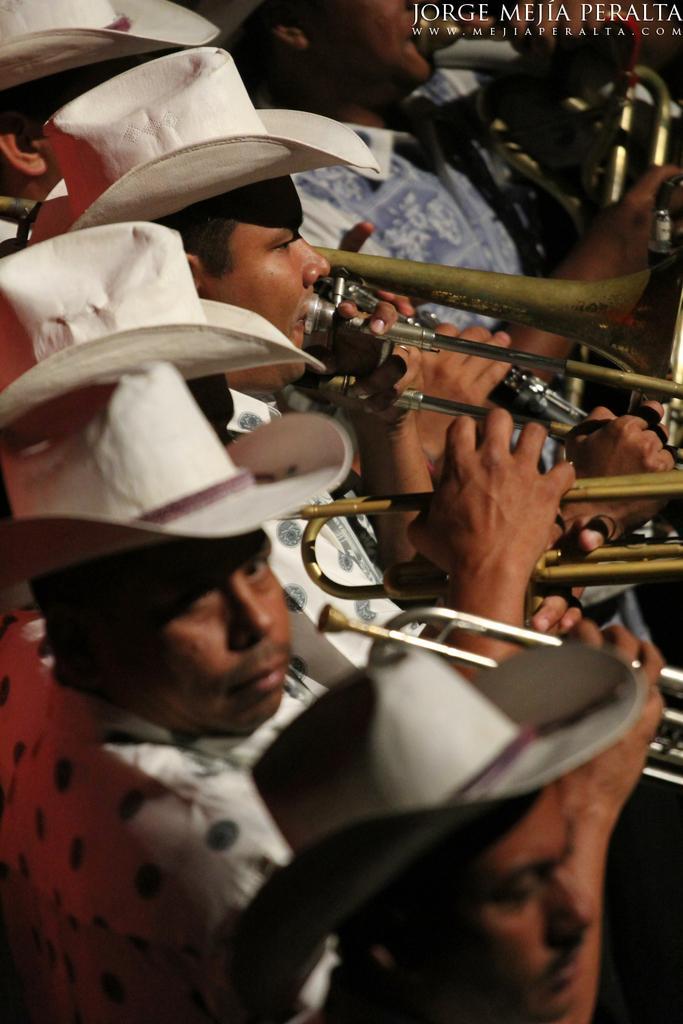Can you describe this image briefly? This image consists of few people wearing white hats are playing trombone. At the top, we can see a text. 